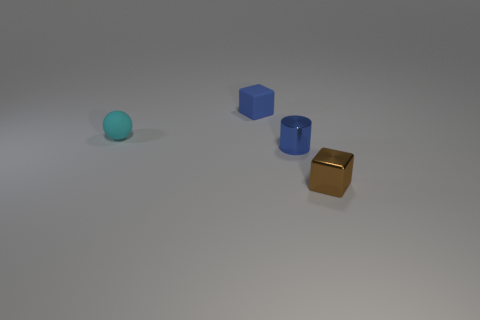What is the color of the other small thing that is made of the same material as the tiny brown object? blue 